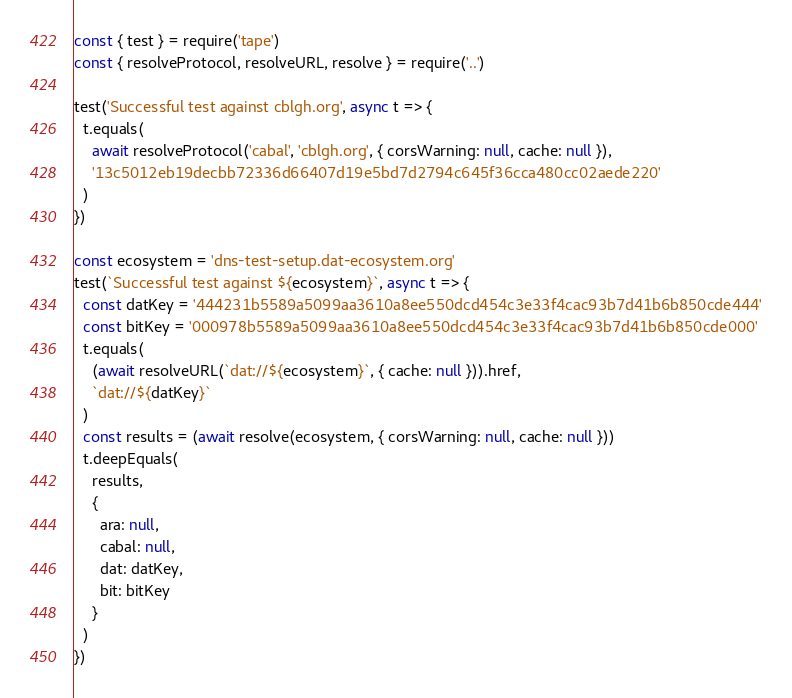Convert code to text. <code><loc_0><loc_0><loc_500><loc_500><_JavaScript_>const { test } = require('tape')
const { resolveProtocol, resolveURL, resolve } = require('..')

test('Successful test against cblgh.org', async t => {
  t.equals(
    await resolveProtocol('cabal', 'cblgh.org', { corsWarning: null, cache: null }),
    '13c5012eb19decbb72336d66407d19e5bd7d2794c645f36cca480cc02aede220'
  )
})

const ecosystem = 'dns-test-setup.dat-ecosystem.org'
test(`Successful test against ${ecosystem}`, async t => {
  const datKey = '444231b5589a5099aa3610a8ee550dcd454c3e33f4cac93b7d41b6b850cde444'
  const bitKey = '000978b5589a5099aa3610a8ee550dcd454c3e33f4cac93b7d41b6b850cde000'
  t.equals(
    (await resolveURL(`dat://${ecosystem}`, { cache: null })).href,
    `dat://${datKey}`
  )
  const results = (await resolve(ecosystem, { corsWarning: null, cache: null }))
  t.deepEquals(
    results,
    {
      ara: null,
      cabal: null,
      dat: datKey,
      bit: bitKey
    }
  )
})
</code> 